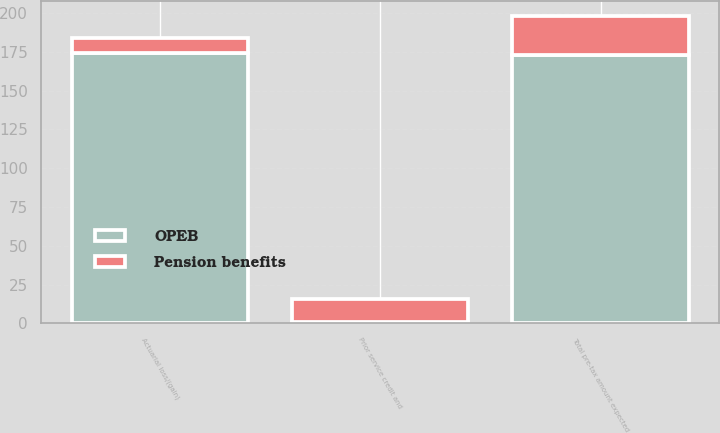<chart> <loc_0><loc_0><loc_500><loc_500><stacked_bar_chart><ecel><fcel>Actuarial loss/(gain)<fcel>Prior service credit and<fcel>Total pre-tax amount expected<nl><fcel>OPEB<fcel>174<fcel>1<fcel>173<nl><fcel>Pension benefits<fcel>10<fcel>15<fcel>25<nl></chart> 